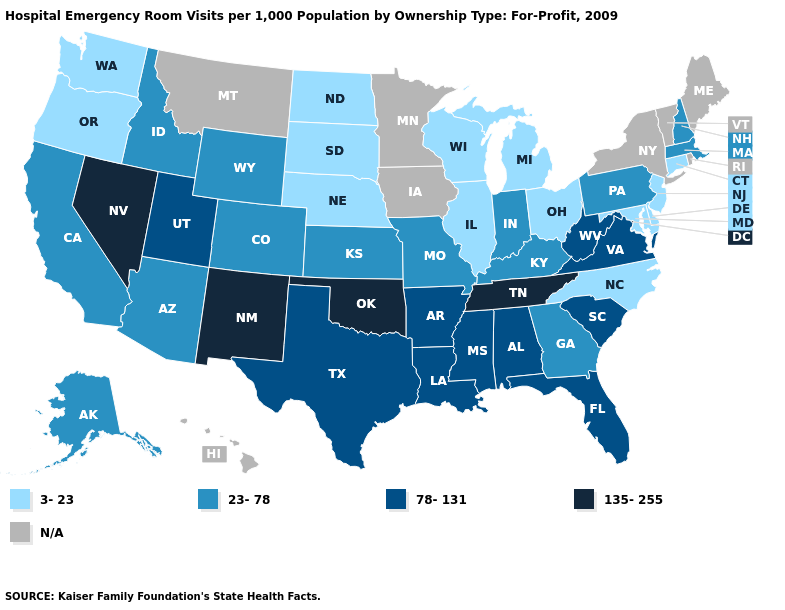What is the value of Maryland?
Keep it brief. 3-23. Among the states that border California , which have the lowest value?
Keep it brief. Oregon. What is the value of Oregon?
Be succinct. 3-23. What is the value of Georgia?
Short answer required. 23-78. Which states have the highest value in the USA?
Write a very short answer. Nevada, New Mexico, Oklahoma, Tennessee. How many symbols are there in the legend?
Concise answer only. 5. What is the value of Illinois?
Answer briefly. 3-23. Does the map have missing data?
Concise answer only. Yes. Name the states that have a value in the range N/A?
Answer briefly. Hawaii, Iowa, Maine, Minnesota, Montana, New York, Rhode Island, Vermont. Is the legend a continuous bar?
Be succinct. No. What is the value of Pennsylvania?
Give a very brief answer. 23-78. Does Wyoming have the lowest value in the West?
Give a very brief answer. No. Among the states that border Arkansas , does Tennessee have the lowest value?
Be succinct. No. Among the states that border Virginia , which have the highest value?
Answer briefly. Tennessee. Does Nevada have the lowest value in the West?
Concise answer only. No. 